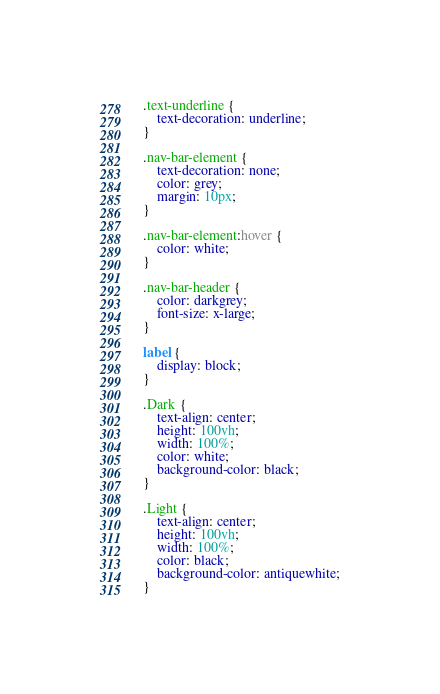<code> <loc_0><loc_0><loc_500><loc_500><_CSS_>
.text-underline {
	text-decoration: underline;
}

.nav-bar-element {
	text-decoration: none;
	color: grey;
	margin: 10px;
}

.nav-bar-element:hover {
	color: white;
}

.nav-bar-header {
	color: darkgrey;
	font-size: x-large;
}

label {
	display: block;
}

.Dark {
	text-align: center;
	height: 100vh;
	width: 100%;
	color: white;
	background-color: black;
}

.Light {
	text-align: center;
	height: 100vh;
	width: 100%;
	color: black;
	background-color: antiquewhite;
}
</code> 